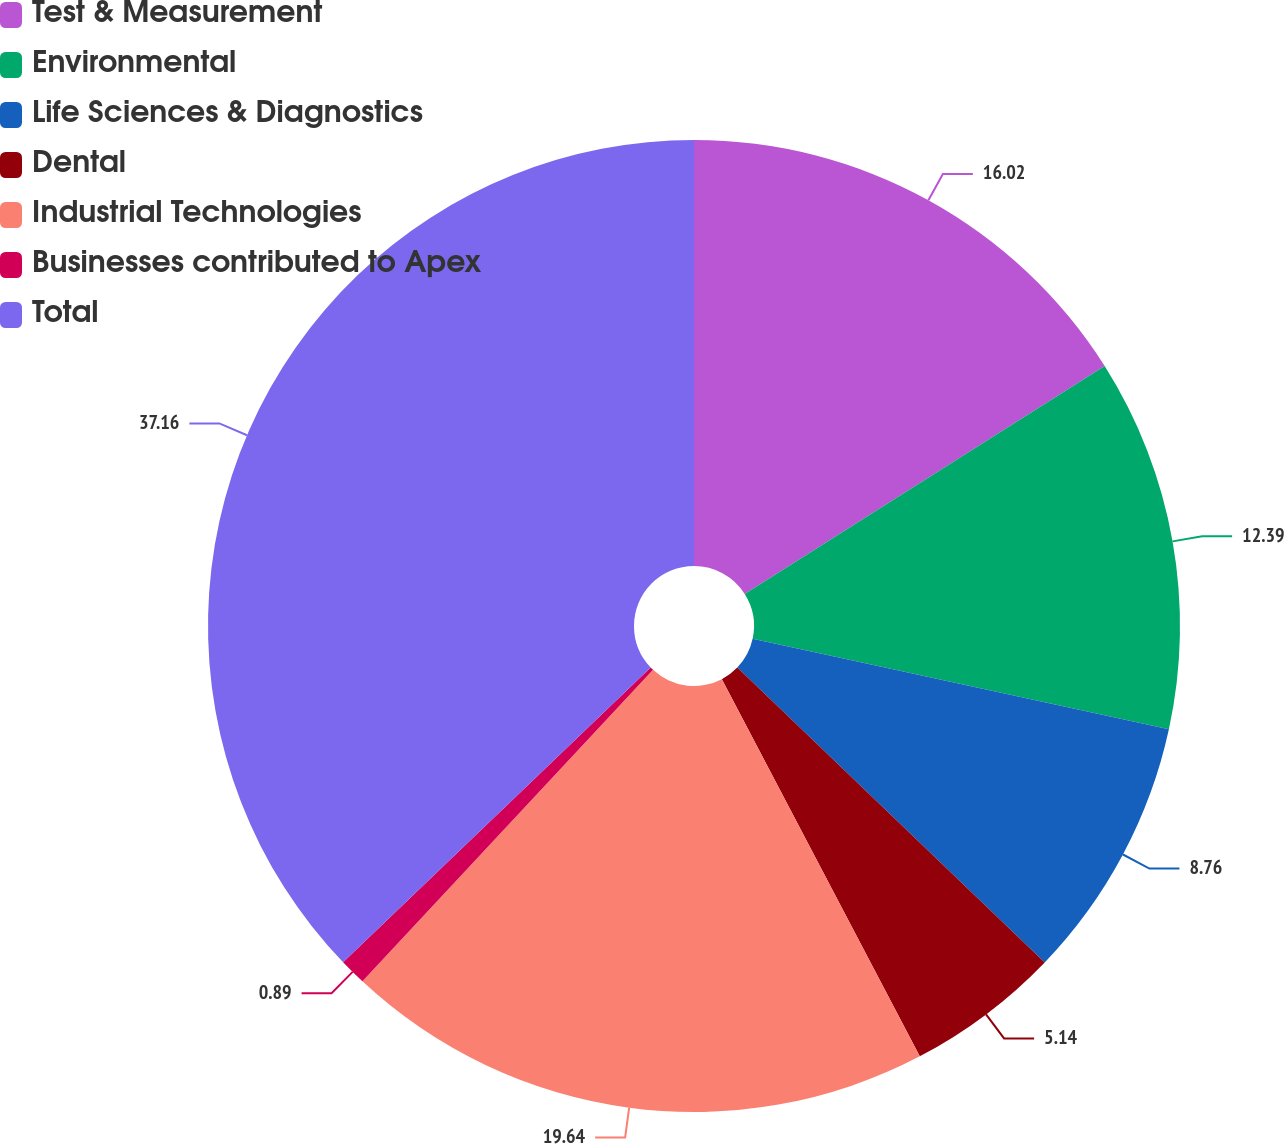Convert chart. <chart><loc_0><loc_0><loc_500><loc_500><pie_chart><fcel>Test & Measurement<fcel>Environmental<fcel>Life Sciences & Diagnostics<fcel>Dental<fcel>Industrial Technologies<fcel>Businesses contributed to Apex<fcel>Total<nl><fcel>16.02%<fcel>12.39%<fcel>8.76%<fcel>5.14%<fcel>19.64%<fcel>0.89%<fcel>37.16%<nl></chart> 